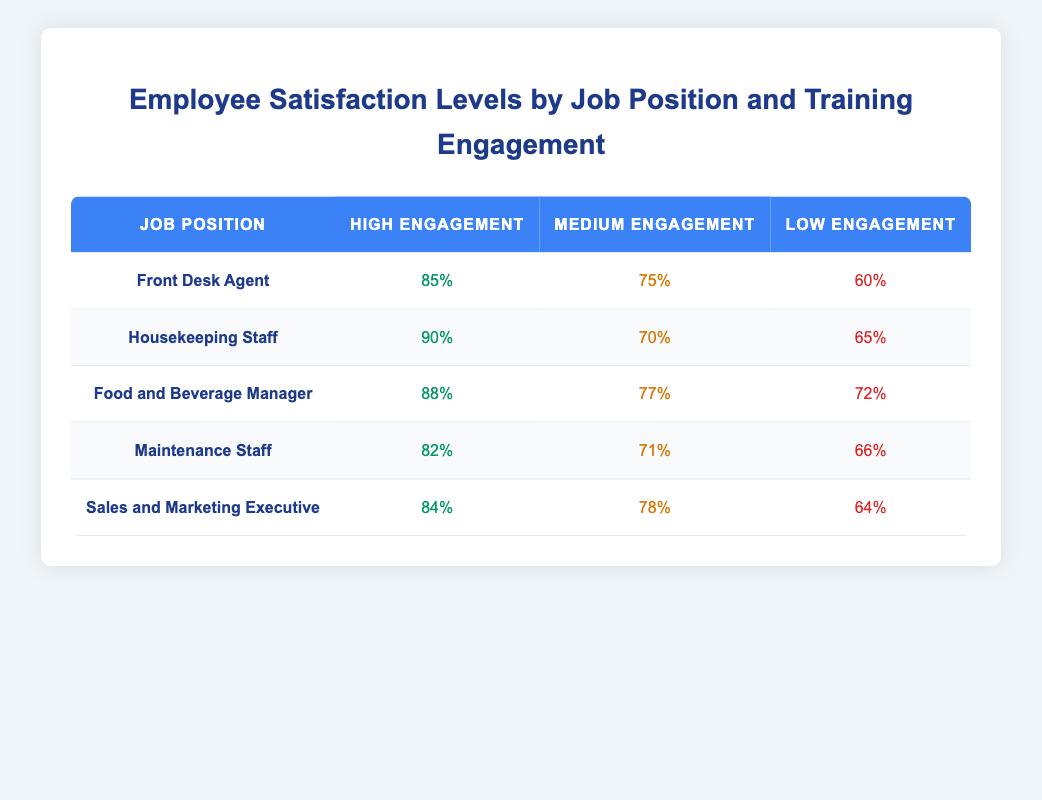What is the satisfaction level for Front Desk Agents with high training engagement? The table indicates that the satisfaction level for Front Desk Agents with high training engagement is 85%.
Answer: 85% Which job position has the highest satisfaction level with medium training engagement? By looking at the table, the Food and Beverage Manager has the highest satisfaction level of 77% when training engagement is medium.
Answer: Food and Beverage Manager What is the average satisfaction level for Housekeeping Staff across all training engagement levels? The satisfaction levels for Housekeeping Staff are 90%, 70%, and 65%. Adding these values gives a total of 225%. Dividing by 3 (the number of engagement levels) results in an average of 75%.
Answer: 75% Is the satisfaction level for Maintenance Staff with low training engagement higher than that of Food and Beverage Managers with low training engagement? The satisfaction level for Maintenance Staff with low training engagement is 66%, while for Food and Beverage Managers, it is 72%. Since 66% is less than 72%, the answer is no.
Answer: No How much higher is the satisfaction level of Housekeeping Staff with high training engagement compared to Sales and Marketing Executives with high training engagement? The satisfaction level for Housekeeping Staff with high training engagement is 90%, and for Sales and Marketing Executives, it is 84%. The difference is 90% - 84% = 6%.
Answer: 6% 